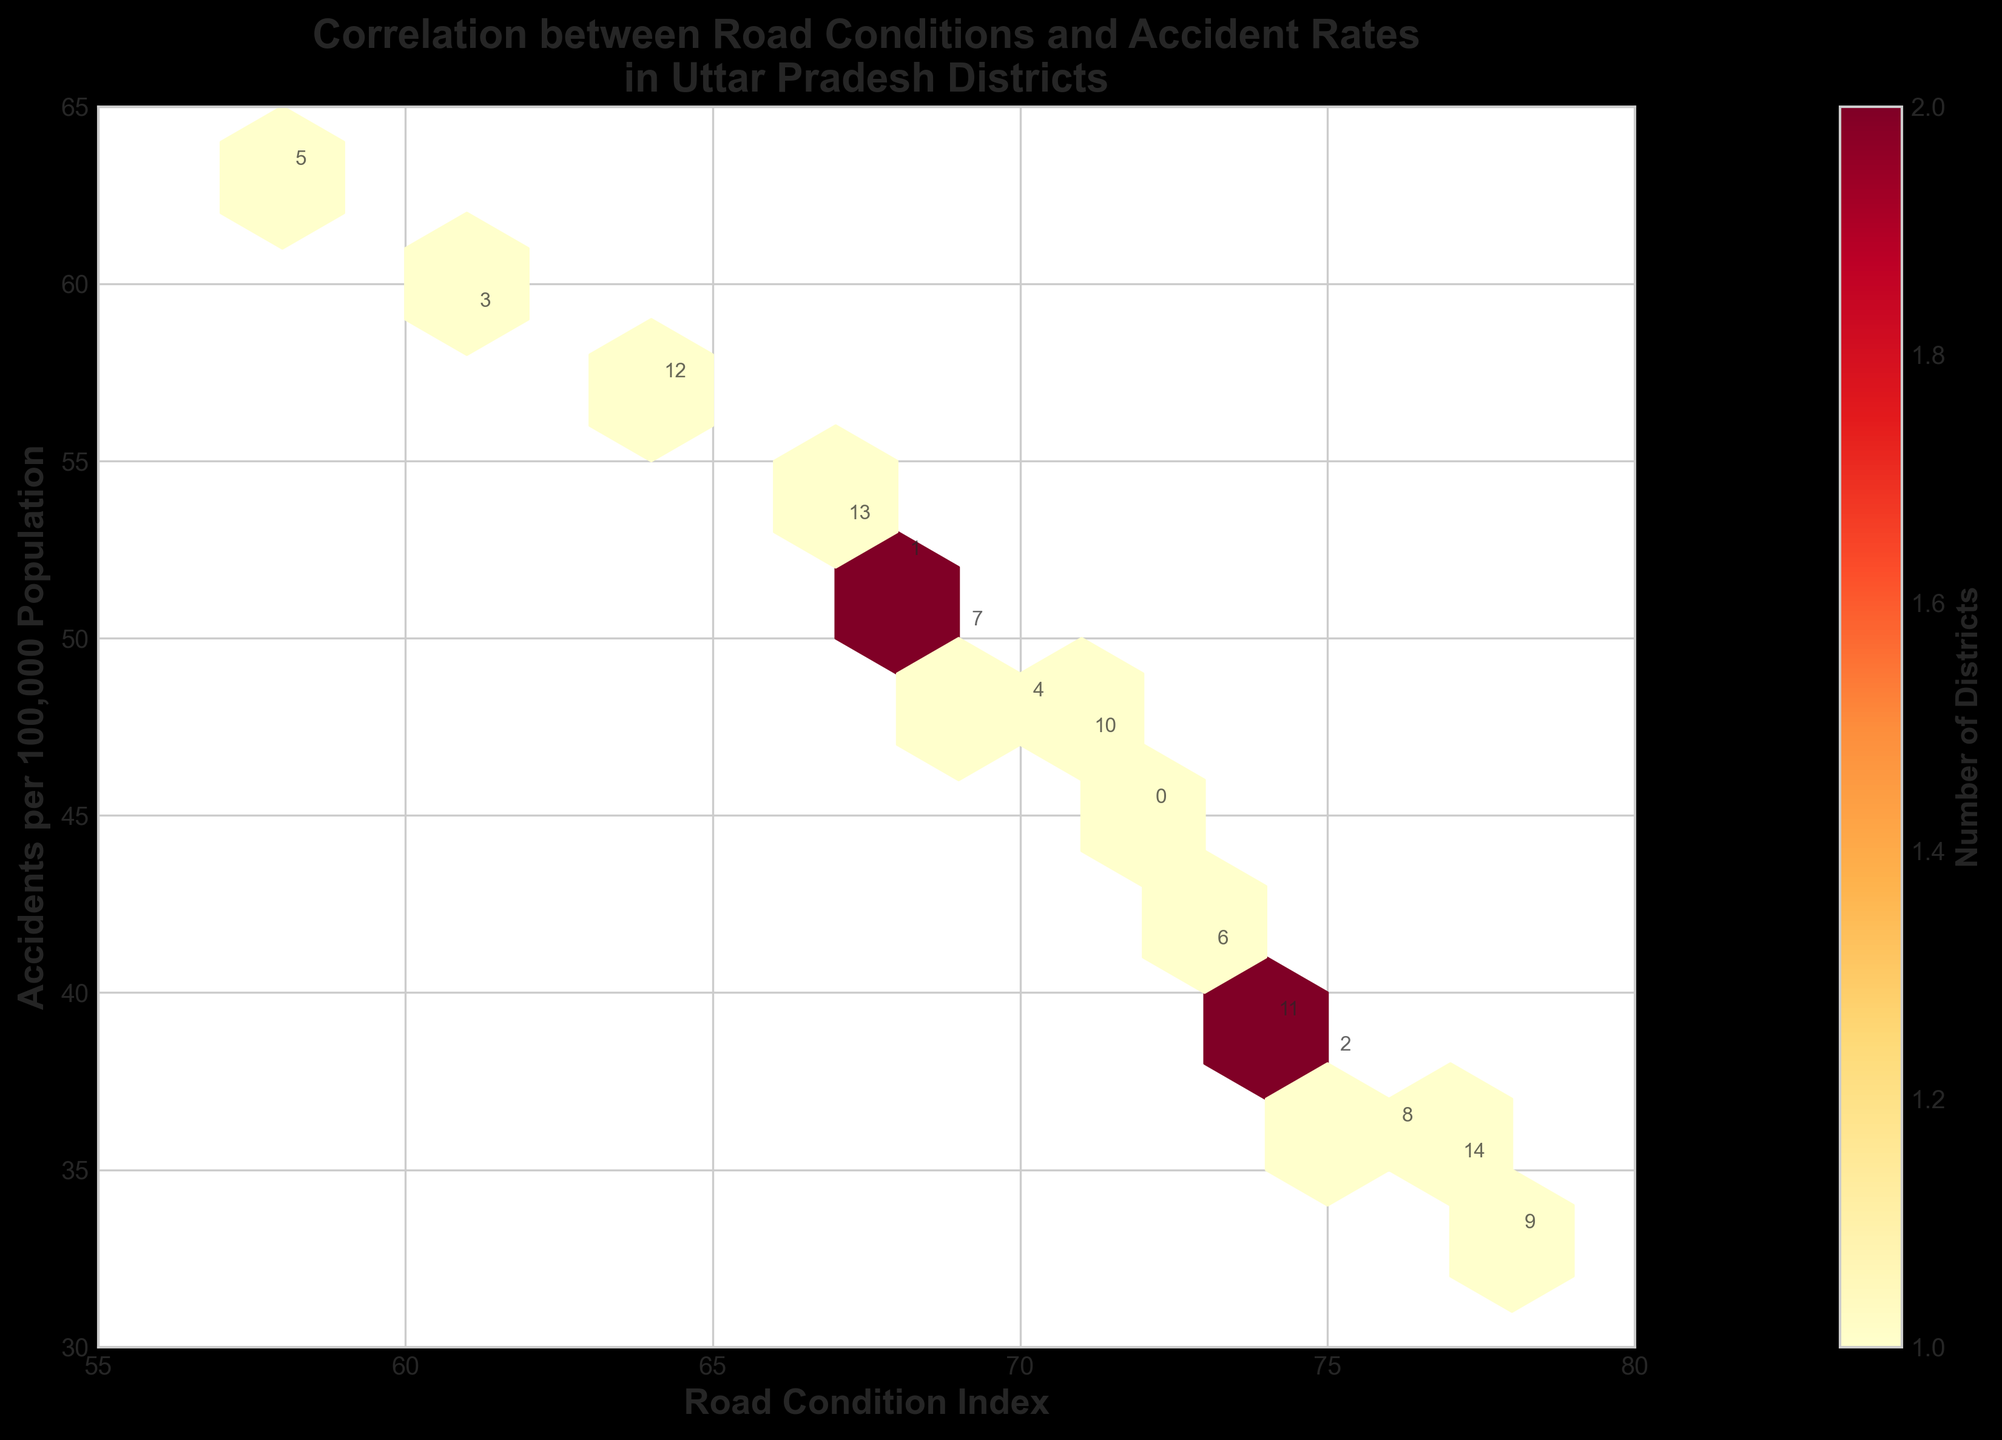What is the title of the plot? The title of the plot is displayed at the top of the figure. It reads "Correlation between Road Conditions and Accident Rates in Uttar Pradesh Districts".
Answer: Correlation between Road Conditions and Accident Rates in Uttar Pradesh Districts What are the labels on the x-axis and y-axis? The x-axis label is displayed at the bottom of the figure and reads "Road Condition Index". The y-axis label is displayed on the left side of the figure and reads "Accidents per 100,000 Population".
Answer: Road Condition Index, Accidents per 100,000 Population Which district has the highest Road Condition Index? By observing the x-axis, the highest Road Condition Index is 78. The annotated district at this point is Lucknow.
Answer: Lucknow Describe the color scale used in the hexbin plot. The color scale is provided by a color bar on the right side of the plot. It uses a range of colors from yellow to red, where yellow represents fewer counts and red represents higher counts.
Answer: Yellow to Red Does a higher Road Condition Index generally relate to a higher or lower accident rate? By examining the hexbin plot, higher Road Condition Index values (towards 80) are associated with generally lower accidents per 100,000 population. This indicates an inverse relationship.
Answer: Lower accident rate Which district has the most accidents per 100,000 population? By looking at the y-axis, the highest value is 63, and the annotated district at this point is Basti.
Answer: Basti How many districts have a Road Condition Index between 70 and 75? By counting the number of data points (hexagons plus annotations) between 70 and 75 on the x-axis, we find there are 5 districts.
Answer: 5 districts Are there any districts with a Road Condition Index below 60? By examining the x-axis, all the districts have Road Condition Index values starting at 58 and above.
Answer: Yes Which district appears to have an average level of accidents per 100,000 population? By looking at the middle of the y-axis, around the average accident rate of approximately 50, the annotated district is Aligarh.
Answer: Aligarh What is the trend observed between the Road Condition Index and accidents per 100,000 population? The trend observed is that with an increase in the Road Condition Index, there is a general decrease in the number of accidents per 100,000 population. This is illustrated by the spread of hexagons becoming sparser and lower in the plot as the Road Condition Index increases.
Answer: A decrease in accident rate 